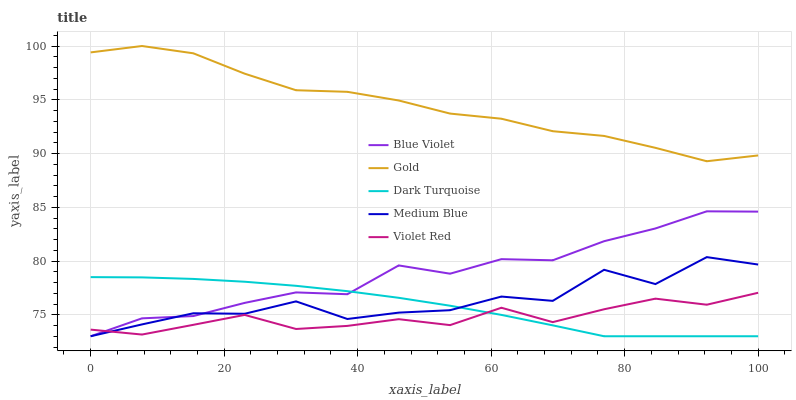Does Medium Blue have the minimum area under the curve?
Answer yes or no. No. Does Medium Blue have the maximum area under the curve?
Answer yes or no. No. Is Violet Red the smoothest?
Answer yes or no. No. Is Violet Red the roughest?
Answer yes or no. No. Does Violet Red have the lowest value?
Answer yes or no. No. Does Medium Blue have the highest value?
Answer yes or no. No. Is Medium Blue less than Gold?
Answer yes or no. Yes. Is Gold greater than Dark Turquoise?
Answer yes or no. Yes. Does Medium Blue intersect Gold?
Answer yes or no. No. 